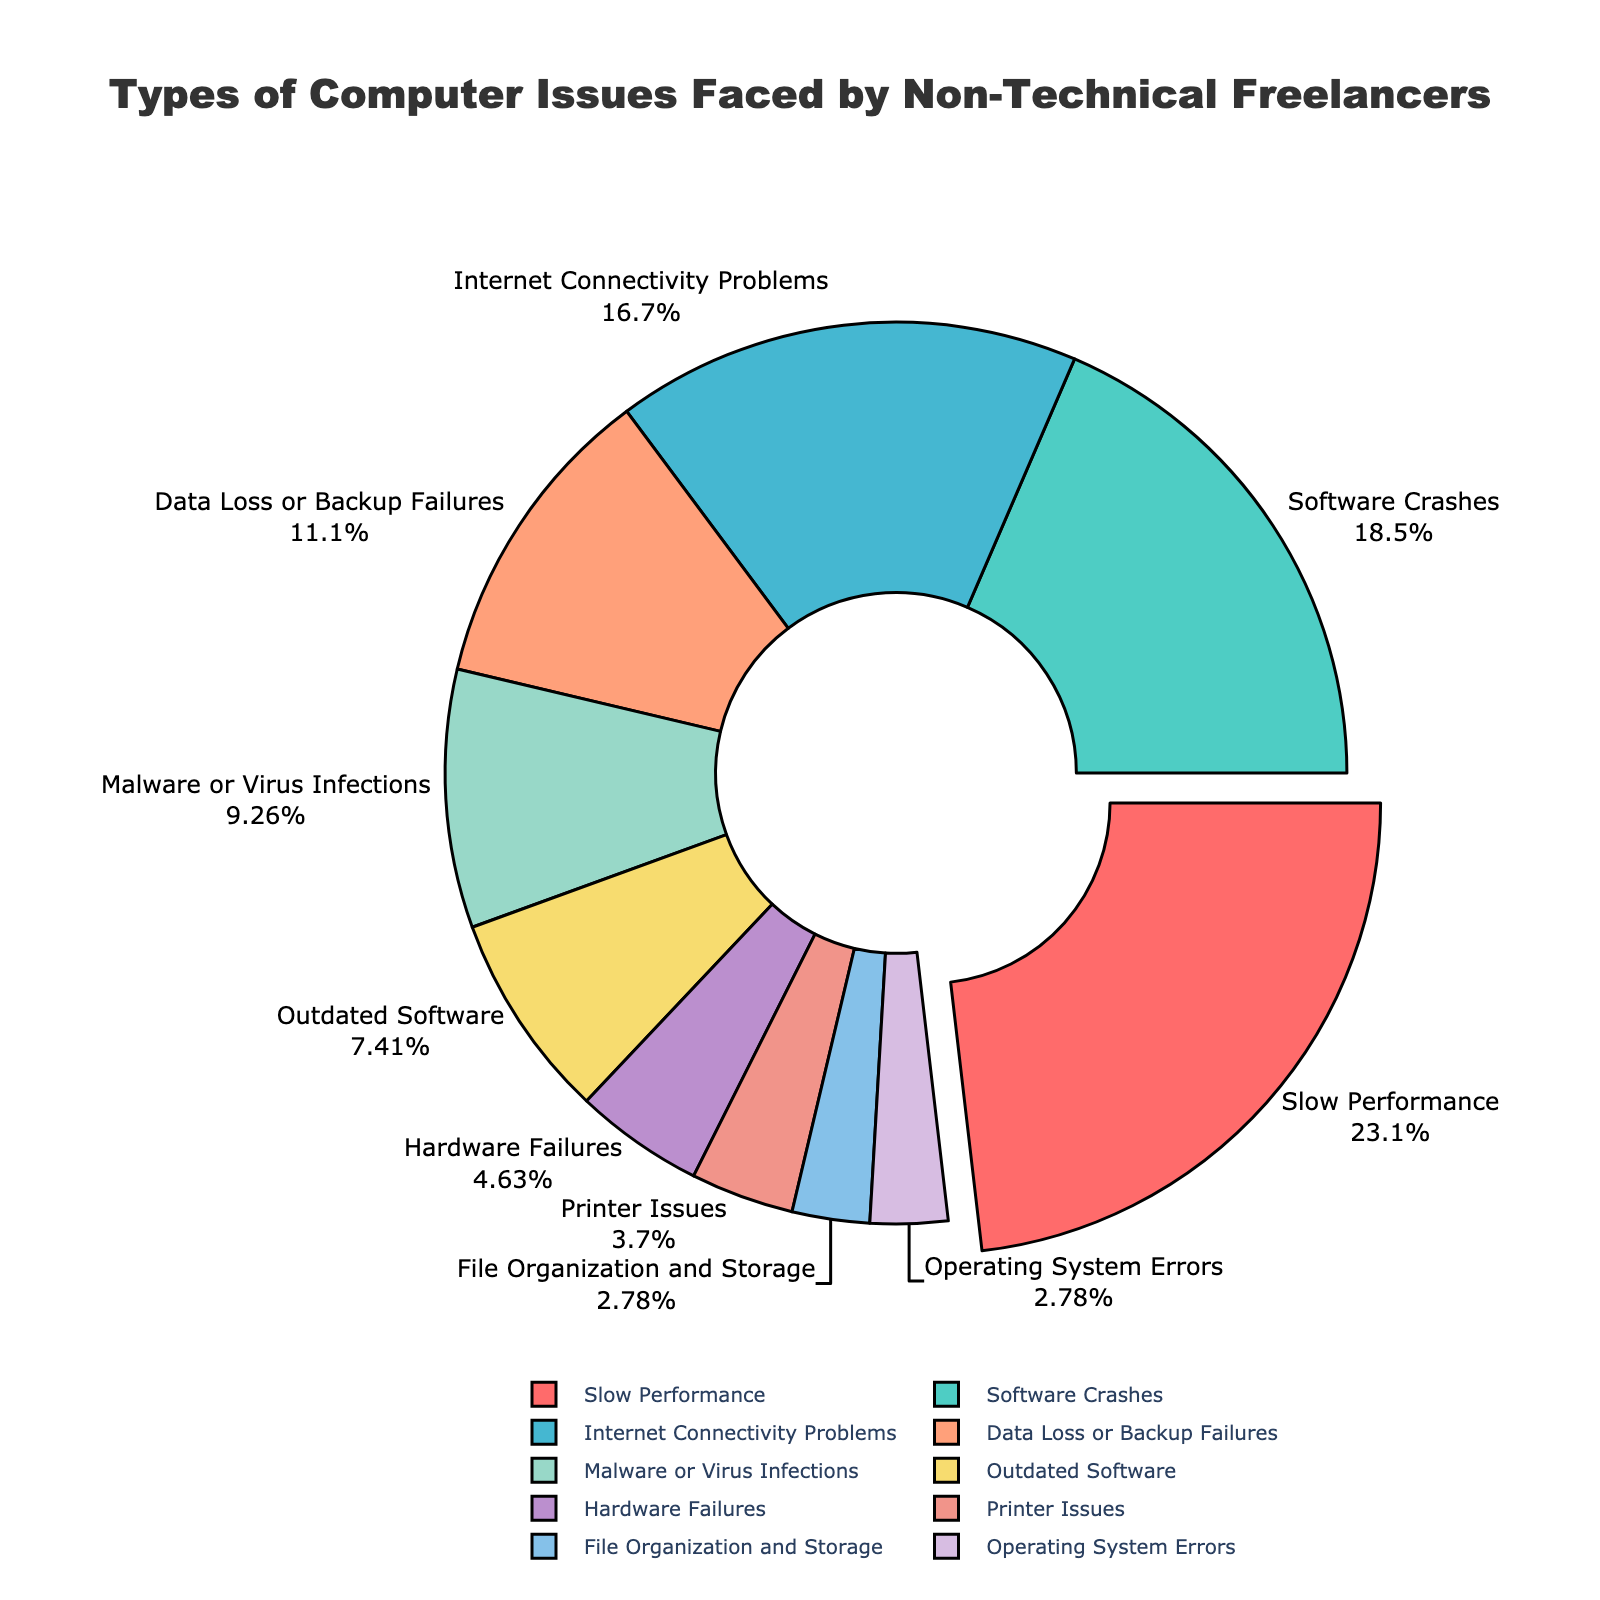Which issue type is faced by the highest percentage of non-technical freelancers? The slice representing "Slow Performance" is pulled out and appears larger, indicating it has the highest percentage.
Answer: Slow Performance What is the combined percentage of freelancers experiencing Internet Connectivity Problems and Data Loss or Backup Failures? Add the percentages for Internet Connectivity Problems (18%) and Data Loss or Backup Failures (12%).
Answer: 30% Which issue type has the smallest percentage? The smallest slice is labeled "Operating System Errors" and "File Organization and Storage", both showing a percentage of 3%.
Answer: Operating System Errors, File Organization and Storage How does the percentage of freelancers facing Printer Issues compare to those facing Hardware Failures? Compare the slices labeled "Printer Issues" (4%) and "Hardware Failures" (5%). Printer Issues has a slightly smaller percentage than Hardware Failures.
Answer: Printer Issues is slightly less What percentage of freelancers face software-related issues (considering Software Crashes, Malware or Virus Infections, Outdated Software)? Sum the percentages of Software Crashes (20%), Malware or Virus Infections (10%), and Outdated Software (8%).
Answer: 38% Which two issue types combined have a total percentage closest to 30%? Review the issue types and their percentages to find a combination that sums to closest to 30%. Data Loss or Backup Failures (12%) and Internet Connectivity Problems (18%) add up to 30%.
Answer: Data Loss or Backup Failures and Internet Connectivity Problems Of the pie chart's visual attributes, which color is used for the slice representing Malware or Virus Infections? The chart uses distinct colors for each slice. The slice for Malware or Virus Infections (10%) is colored yellow.
Answer: Yellow Is the percentage of freelancers facing Software Crashes greater than the percentage facing Slow Performance? Compare the slices labeled "Software Crashes" (20%) and "Slow Performance" (25%). Software Crashes has a smaller percentage than Slow Performance.
Answer: No How does the total percentage of hardware-related issues compare to software-related issues (considering Hardware Failures and Printer Issues for hardware vs Software Crashes, Malware or Virus Infections, Outdated Software for software)? Hardware-related issues (Hardware Failures 5% + Printer Issues 4%) total 9%. Software-related issues (Software Crashes 20% + Malware or Virus Infections 10% + Outdated Software 8%) total 38%. Hardware-related issues are significantly less.
Answer: Hardware issues are significantly less 